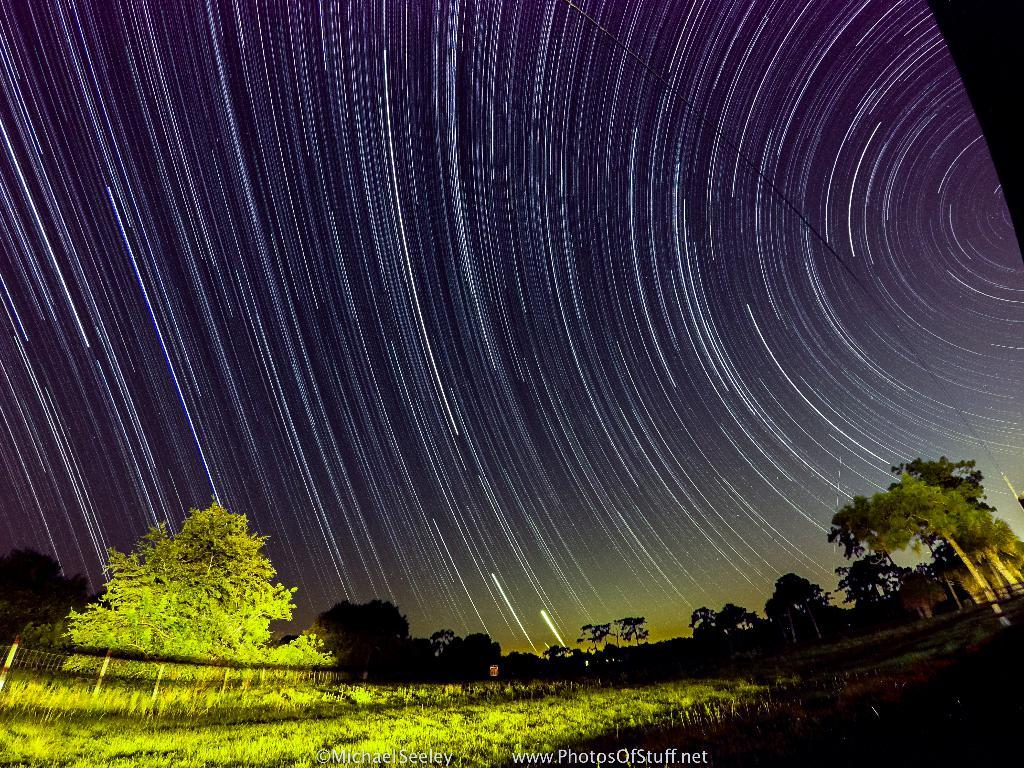What type of vegetation can be seen in the image? There are plants and trees in the image. What is visible in the background of the image? The sky is visible in the background of the image. What is written at the bottom of the image? There is text written at the bottom of the image. How does the image appear to be processed or altered? The image has a photo effect. What type of bread is being used to create the image? There is no bread present in the image, and it is not being used to create the image. 